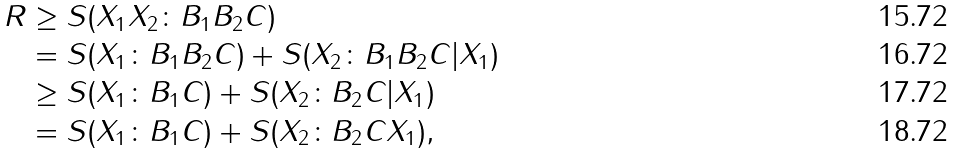Convert formula to latex. <formula><loc_0><loc_0><loc_500><loc_500>R & \geq S ( X _ { 1 } X _ { 2 } \colon B _ { 1 } B _ { 2 } C ) \\ & = S ( X _ { 1 } \colon B _ { 1 } B _ { 2 } C ) + S ( X _ { 2 } \colon B _ { 1 } B _ { 2 } C | X _ { 1 } ) \\ & \geq S ( X _ { 1 } \colon B _ { 1 } C ) + S ( X _ { 2 } \colon B _ { 2 } C | X _ { 1 } ) \\ & = S ( X _ { 1 } \colon B _ { 1 } C ) + S ( X _ { 2 } \colon B _ { 2 } C X _ { 1 } ) ,</formula> 